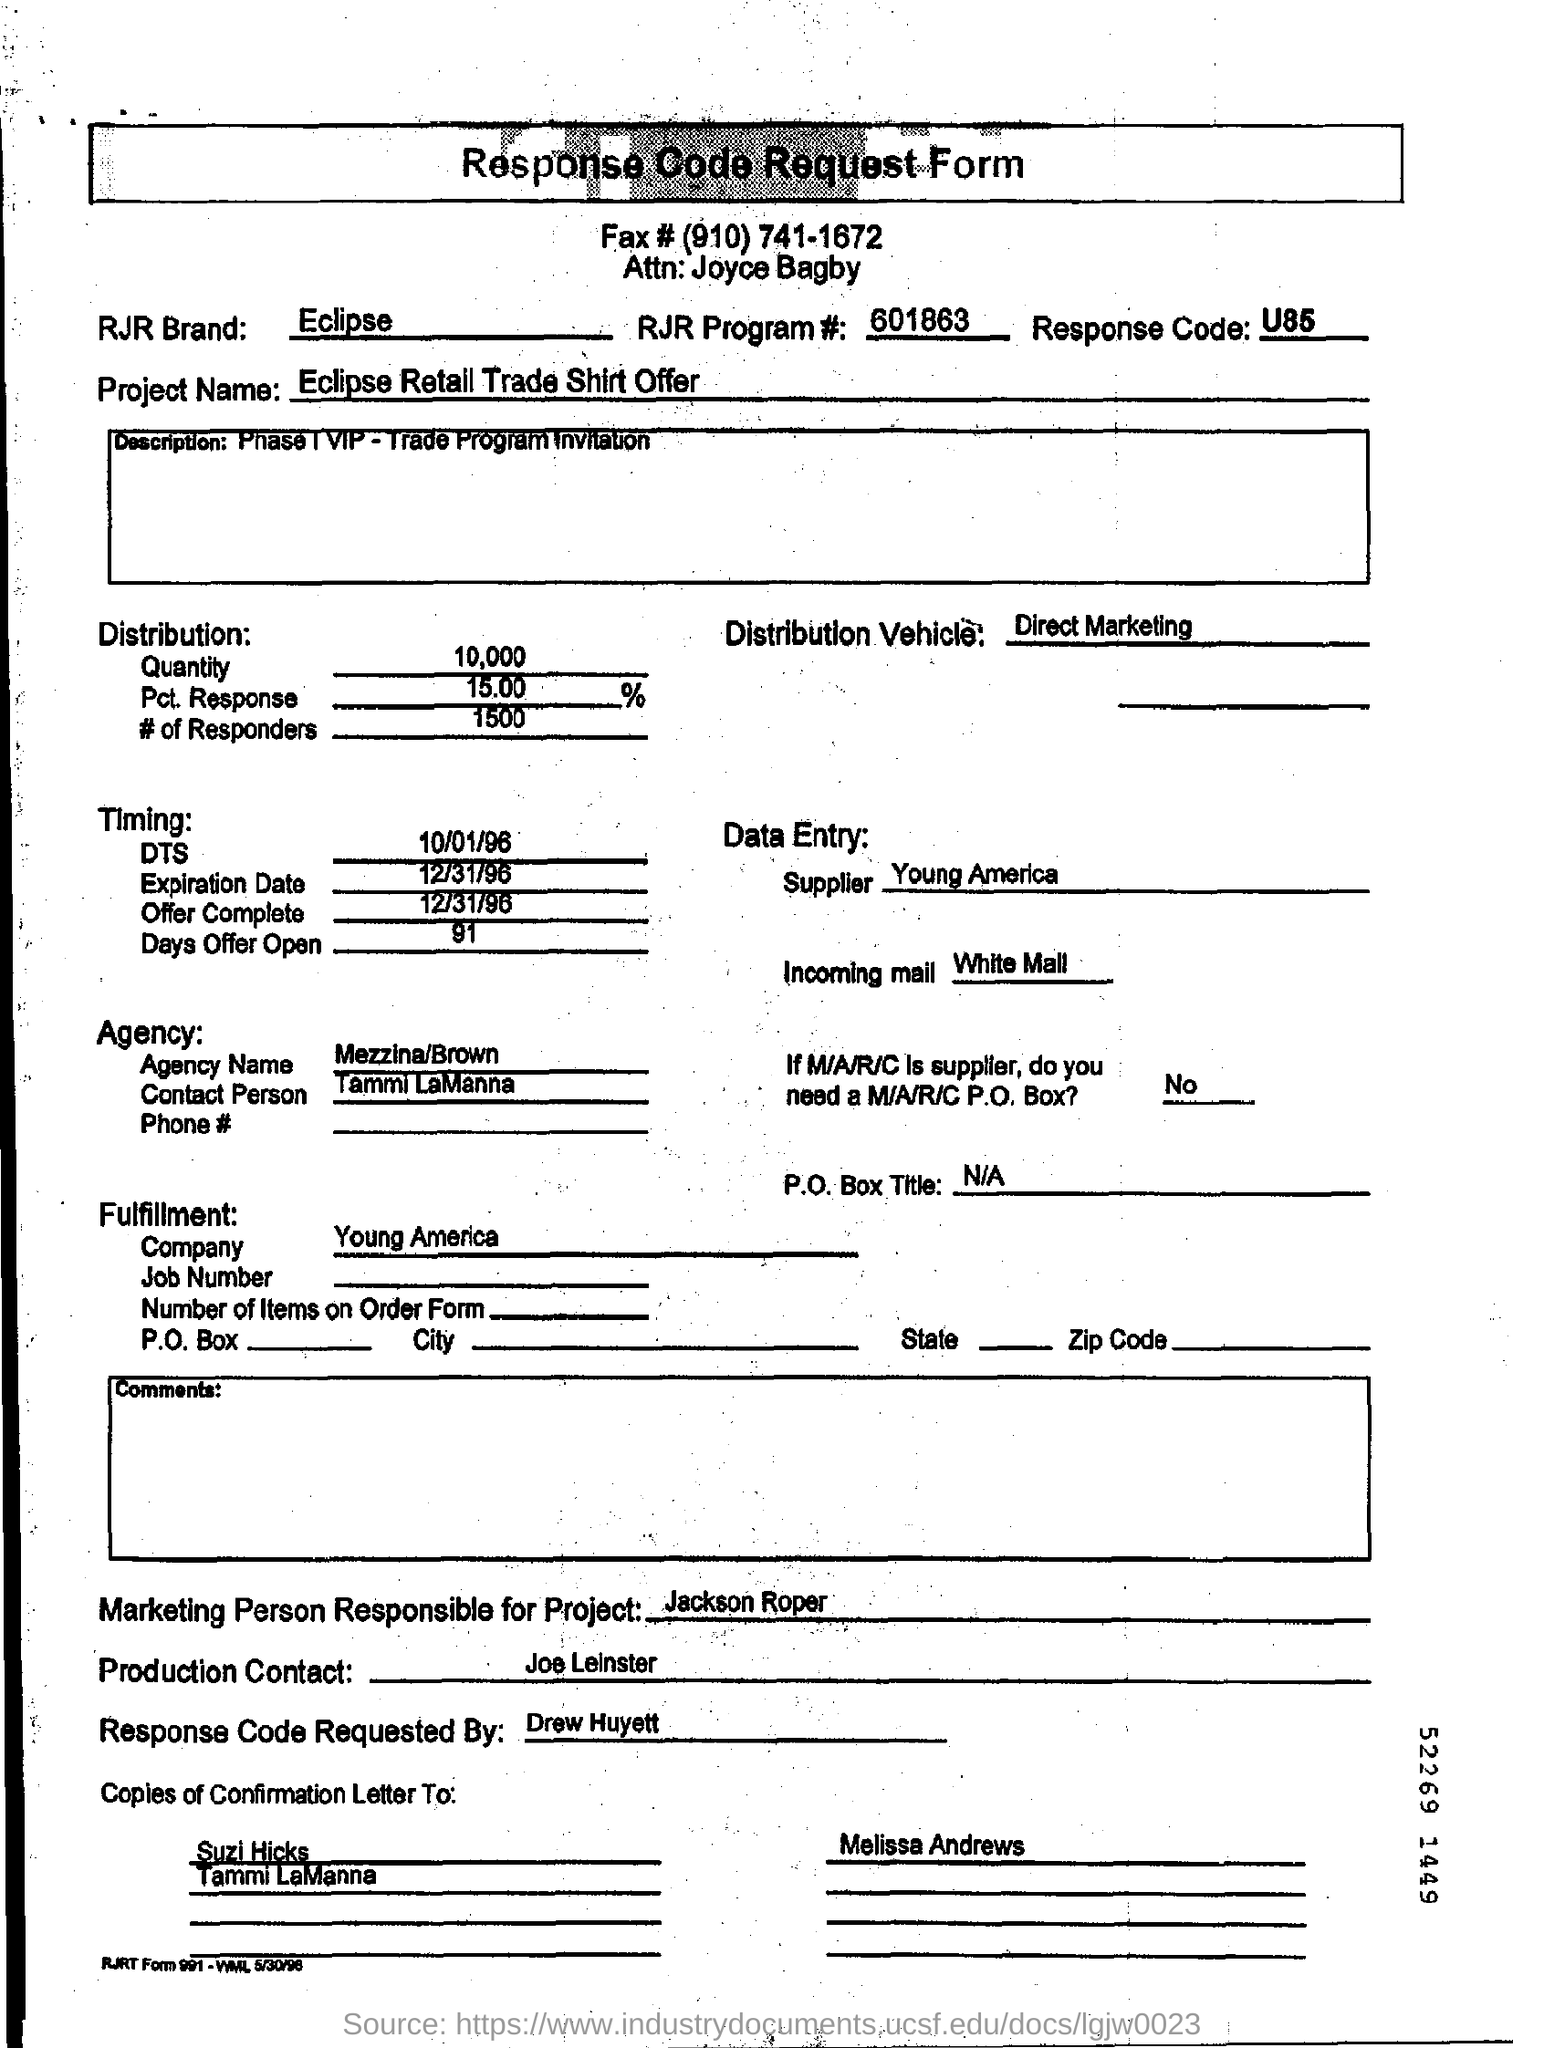What is RJR program number mentioned in the response code request form?
Offer a very short reply. 601863. What is RJR program number mentioned on the response code request form?
Ensure brevity in your answer.  601863. What is the response code?
Your answer should be very brief. U85. How many number of responders are mentioned on the response code request form?
Your answer should be compact. 1500. How long is the offer open?
Provide a short and direct response. 91. What is the name of the supplier?
Your response must be concise. Young America. Who is the marketing person responsible for project?
Your answer should be very brief. Jackson Roper. Who is requesting the response code confirmation?
Make the answer very short. Drew Huyett. 